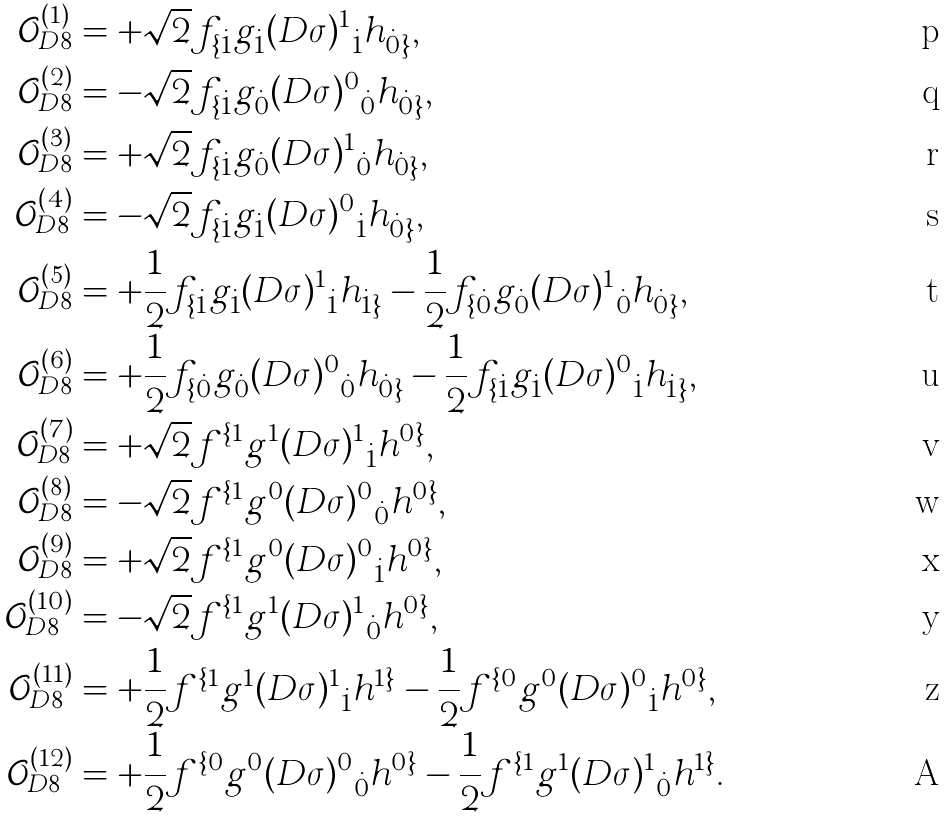Convert formula to latex. <formula><loc_0><loc_0><loc_500><loc_500>\mathcal { O } _ { D 8 } ^ { ( 1 ) } & = + \sqrt { 2 } f _ { \{ \dot { 1 } } g _ { \dot { 1 } } { ( D \sigma ) ^ { 1 } } _ { \dot { 1 } } h _ { \dot { 0 } \} } , \\ \mathcal { O } _ { D 8 } ^ { ( 2 ) } & = - \sqrt { 2 } f _ { \{ \dot { 1 } } g _ { \dot { 0 } } { ( D \sigma ) ^ { 0 } } _ { \dot { 0 } } h _ { \dot { 0 } \} } , \\ \mathcal { O } _ { D 8 } ^ { ( 3 ) } & = + \sqrt { 2 } f _ { \{ \dot { 1 } } g _ { \dot { 0 } } { ( D \sigma ) ^ { 1 } } _ { \dot { 0 } } h _ { \dot { 0 } \} } , \\ \mathcal { O } _ { D 8 } ^ { ( 4 ) } & = - \sqrt { 2 } f _ { \{ \dot { 1 } } g _ { \dot { 1 } } { ( D \sigma ) ^ { 0 } } _ { \dot { 1 } } h _ { \dot { 0 } \} } , \\ \mathcal { O } _ { D 8 } ^ { ( 5 ) } & = + \frac { 1 } { 2 } f _ { \{ \dot { 1 } } g _ { \dot { 1 } } { ( D \sigma ) ^ { 1 } } _ { \dot { 1 } } h _ { \dot { 1 } \} } - \frac { 1 } { 2 } f _ { \{ \dot { 0 } } g _ { \dot { 0 } } { ( D \sigma ) ^ { 1 } } _ { \dot { 0 } } h _ { \dot { 0 } \} } , \\ \mathcal { O } _ { D 8 } ^ { ( 6 ) } & = + \frac { 1 } { 2 } f _ { \{ \dot { 0 } } g _ { \dot { 0 } } { ( D \sigma ) ^ { 0 } } _ { \dot { 0 } } h _ { \dot { 0 } \} } - \frac { 1 } { 2 } f _ { \{ \dot { 1 } } g _ { \dot { 1 } } { ( D \sigma ) ^ { 0 } } _ { \dot { 1 } } h _ { \dot { 1 } \} } , \\ \mathcal { O } _ { D 8 } ^ { ( 7 ) } & = + \sqrt { 2 } f ^ { \{ 1 } g ^ { 1 } { ( D \sigma ) ^ { 1 } } _ { \dot { 1 } } h ^ { 0 \} } , \\ \mathcal { O } _ { D 8 } ^ { ( 8 ) } & = - \sqrt { 2 } f ^ { \{ 1 } g ^ { 0 } { ( D \sigma ) ^ { 0 } } _ { \dot { 0 } } h ^ { 0 \} } , \\ \mathcal { O } _ { D 8 } ^ { ( 9 ) } & = + \sqrt { 2 } f ^ { \{ 1 } g ^ { 0 } { ( D \sigma ) ^ { 0 } } _ { \dot { 1 } } h ^ { 0 \} } , \\ \mathcal { O } _ { D 8 } ^ { ( 1 0 ) } & = - \sqrt { 2 } f ^ { \{ 1 } g ^ { 1 } { ( D \sigma ) ^ { 1 } } _ { \dot { 0 } } h ^ { 0 \} } , \\ \mathcal { O } _ { D 8 } ^ { ( 1 1 ) } & = + \frac { 1 } { 2 } f ^ { \{ 1 } g ^ { 1 } { ( D \sigma ) ^ { 1 } } _ { \dot { 1 } } h ^ { 1 \} } - \frac { 1 } { 2 } f ^ { \{ 0 } g ^ { 0 } { ( D \sigma ) ^ { 0 } } _ { \dot { 1 } } h ^ { 0 \} } , \\ \mathcal { O } _ { D 8 } ^ { ( 1 2 ) } & = + \frac { 1 } { 2 } f ^ { \{ 0 } g ^ { 0 } { ( D \sigma ) ^ { 0 } } _ { \dot { 0 } } h ^ { 0 \} } - \frac { 1 } { 2 } f ^ { \{ 1 } g ^ { 1 } { ( D \sigma ) ^ { 1 } } _ { \dot { 0 } } h ^ { 1 \} } .</formula> 